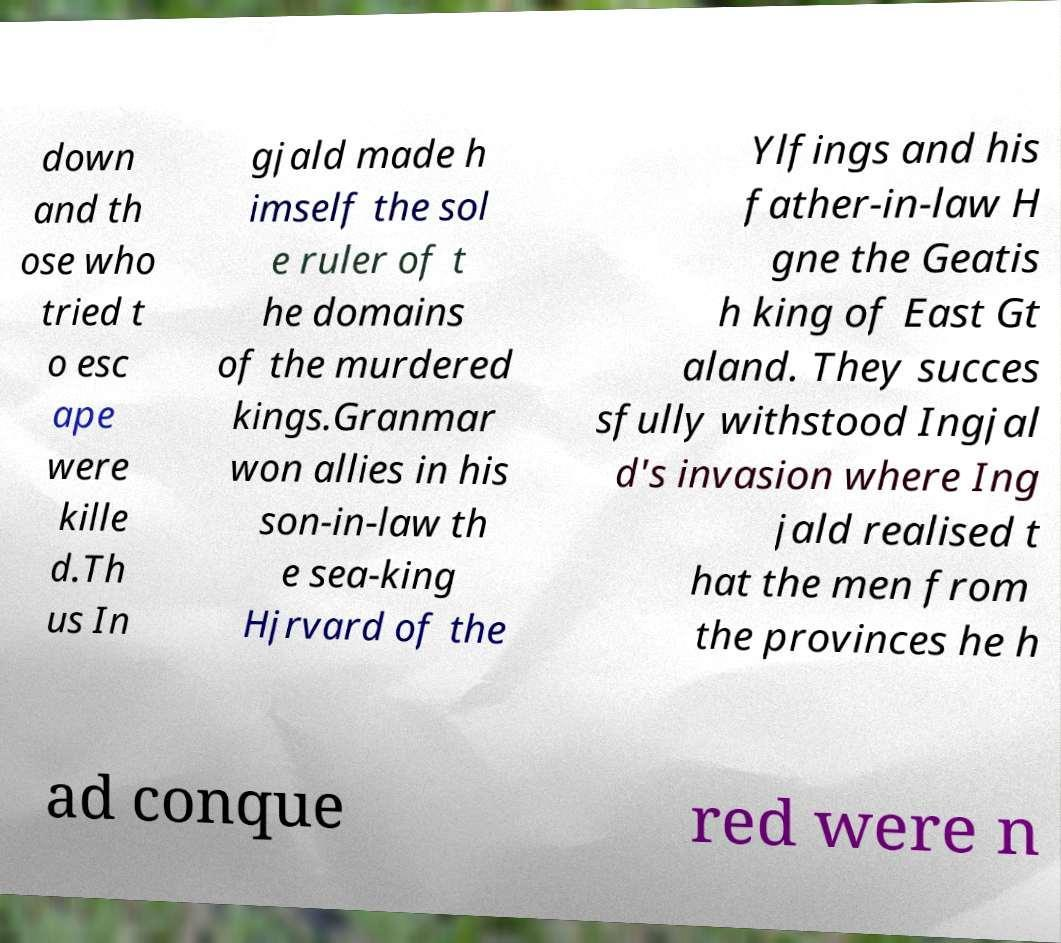Please read and relay the text visible in this image. What does it say? down and th ose who tried t o esc ape were kille d.Th us In gjald made h imself the sol e ruler of t he domains of the murdered kings.Granmar won allies in his son-in-law th e sea-king Hjrvard of the Ylfings and his father-in-law H gne the Geatis h king of East Gt aland. They succes sfully withstood Ingjal d's invasion where Ing jald realised t hat the men from the provinces he h ad conque red were n 